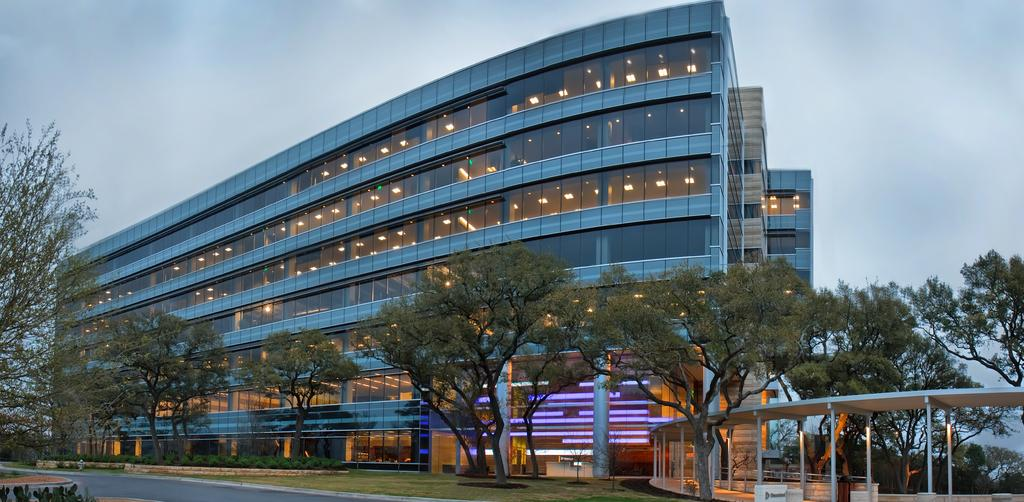What is the main feature of the image? There is a road in the image. What can be seen on the right side of the image? There are trees on the right side of the image. Is there any path visible in the image? Yes, there is a path in the image. What is located in the background of the image? There is a big building in the background of the image. How would you describe the sky in the image? The sky is cloudy in the background of the image. How many sisters are playing on the road in the image? There are no sisters present in the image; it only features a road, trees, a path, a big building, and a cloudy sky. 